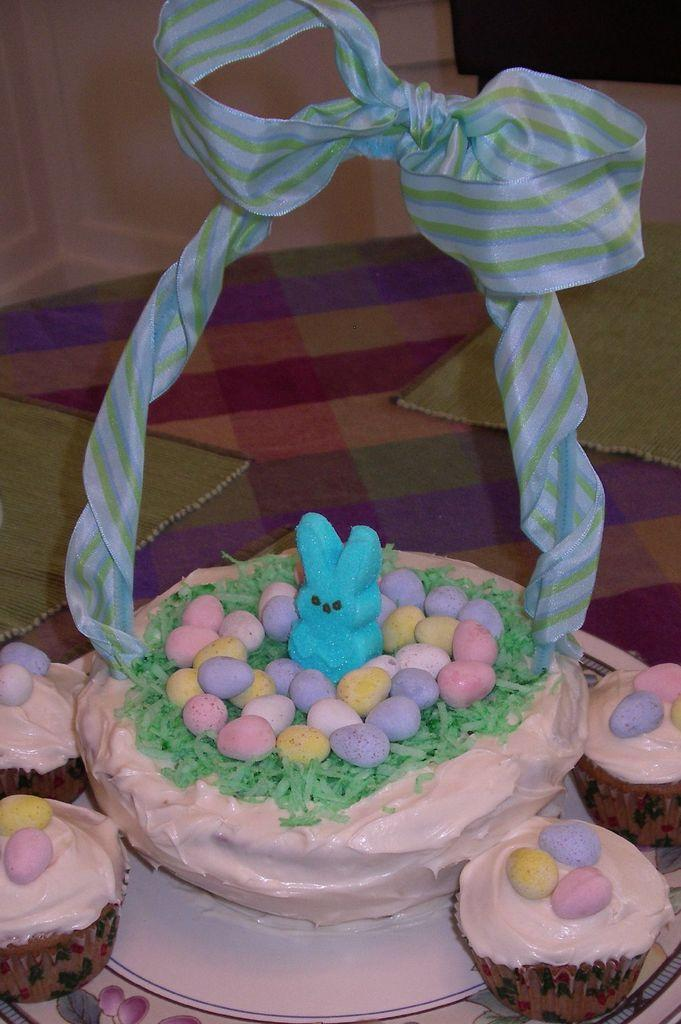What type of food items are present in the image? There are eggs in the image. What other object can be seen in the image? There is a toy in the image. What are the objects used for holding or carrying items in the image? There are baskets in the image. What color is the mat in the background of the image? There is a green color mat in the background of the image. What type of desk is visible in the image? There is no desk present in the image. Is there a laborer performing any tasks in the image? There is no laborer or any tasks being performed in the image. 